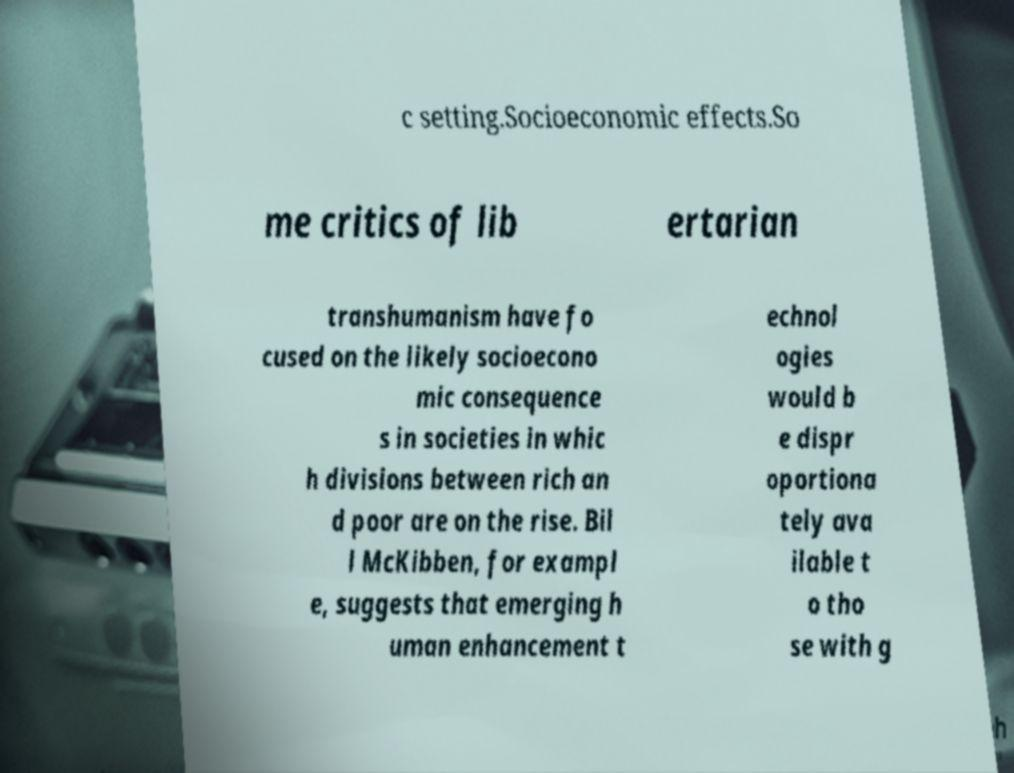Please identify and transcribe the text found in this image. c setting.Socioeconomic effects.So me critics of lib ertarian transhumanism have fo cused on the likely socioecono mic consequence s in societies in whic h divisions between rich an d poor are on the rise. Bil l McKibben, for exampl e, suggests that emerging h uman enhancement t echnol ogies would b e dispr oportiona tely ava ilable t o tho se with g 